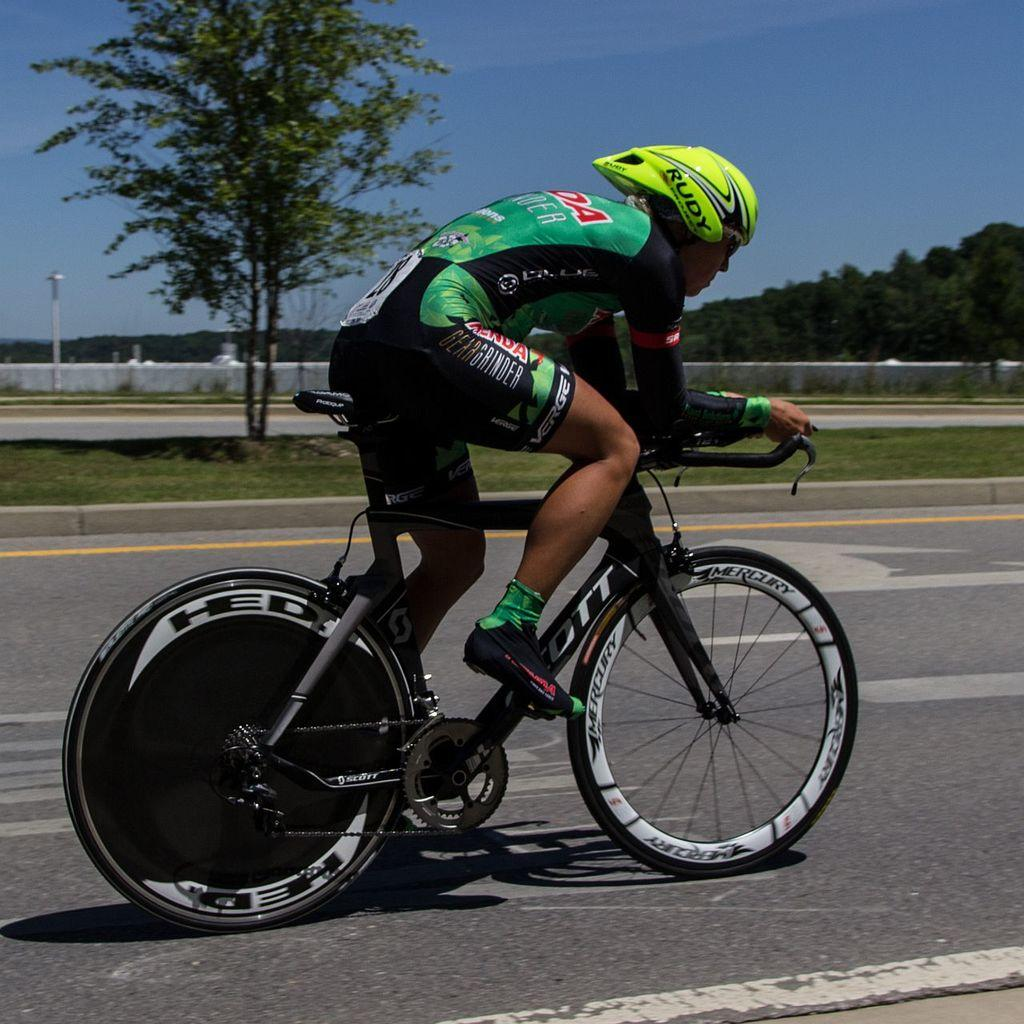What is the main subject of the image? There is a person in the image. What is the person doing in the image? The person is on a bicycle. What can be seen in the background of the image? There are trees, grassland, poles, and the sky visible in the background of the image. How many toes can be seen on the person's feet in the image? The image does not show the person's feet, so the number of toes cannot be determined. 